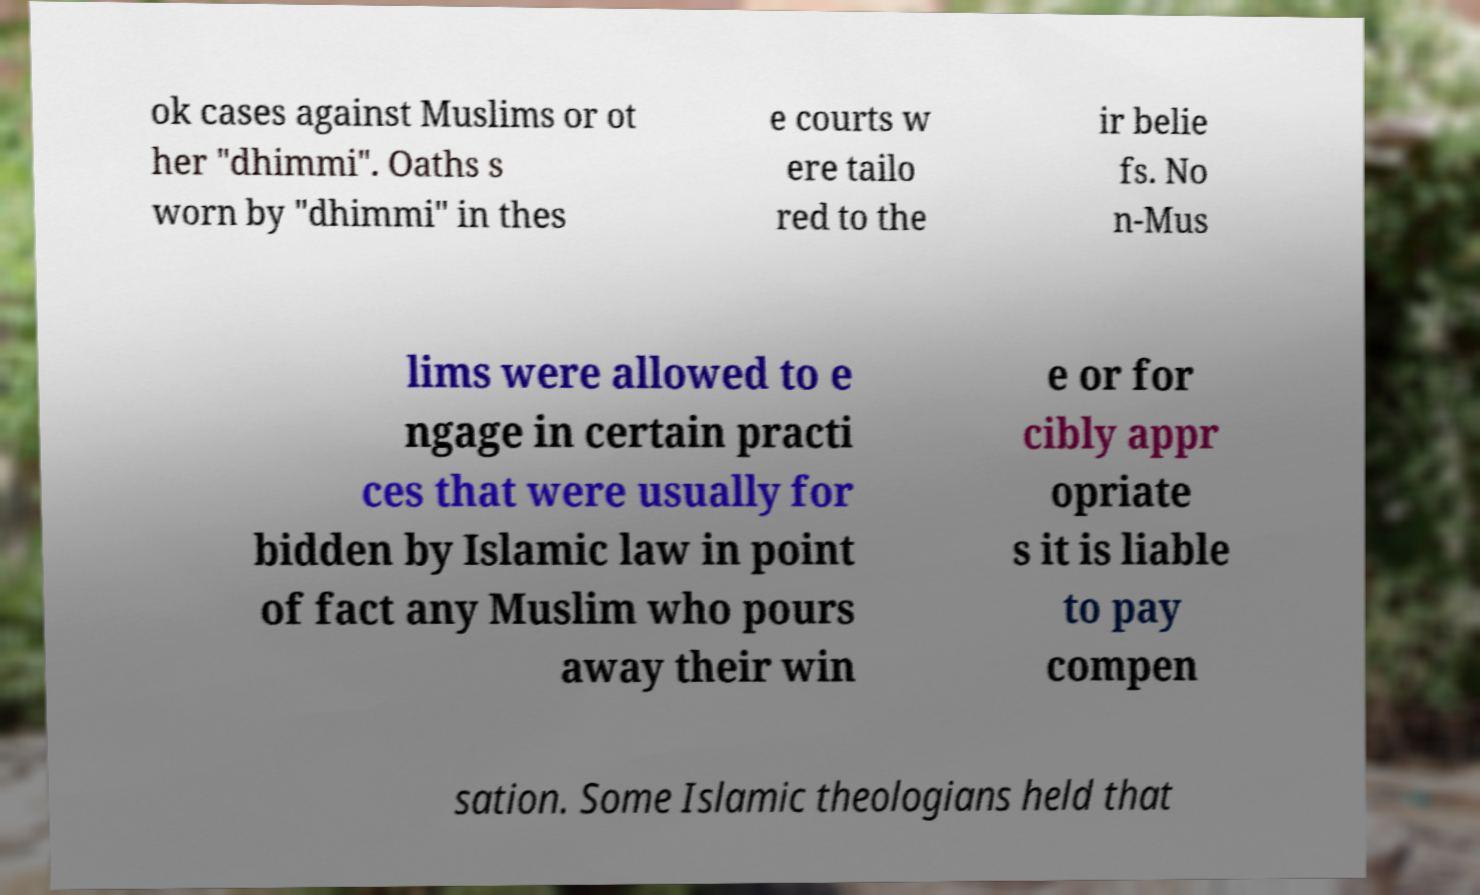Please read and relay the text visible in this image. What does it say? ok cases against Muslims or ot her "dhimmi". Oaths s worn by "dhimmi" in thes e courts w ere tailo red to the ir belie fs. No n-Mus lims were allowed to e ngage in certain practi ces that were usually for bidden by Islamic law in point of fact any Muslim who pours away their win e or for cibly appr opriate s it is liable to pay compen sation. Some Islamic theologians held that 